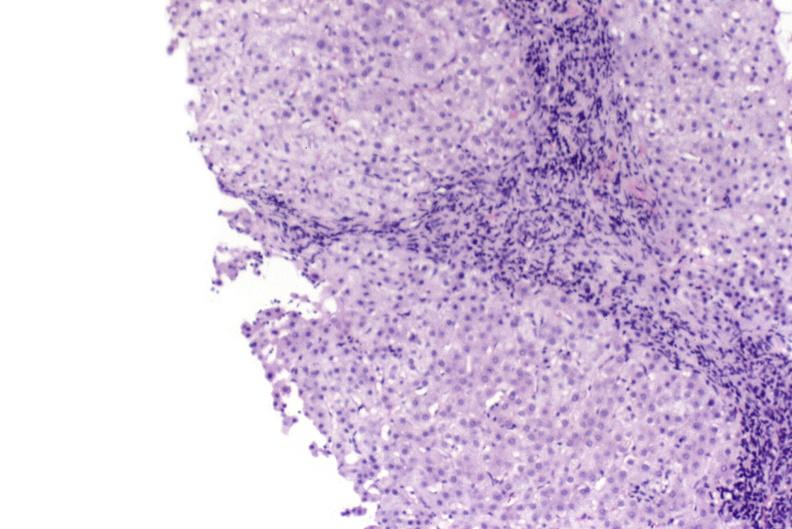s liver present?
Answer the question using a single word or phrase. Yes 